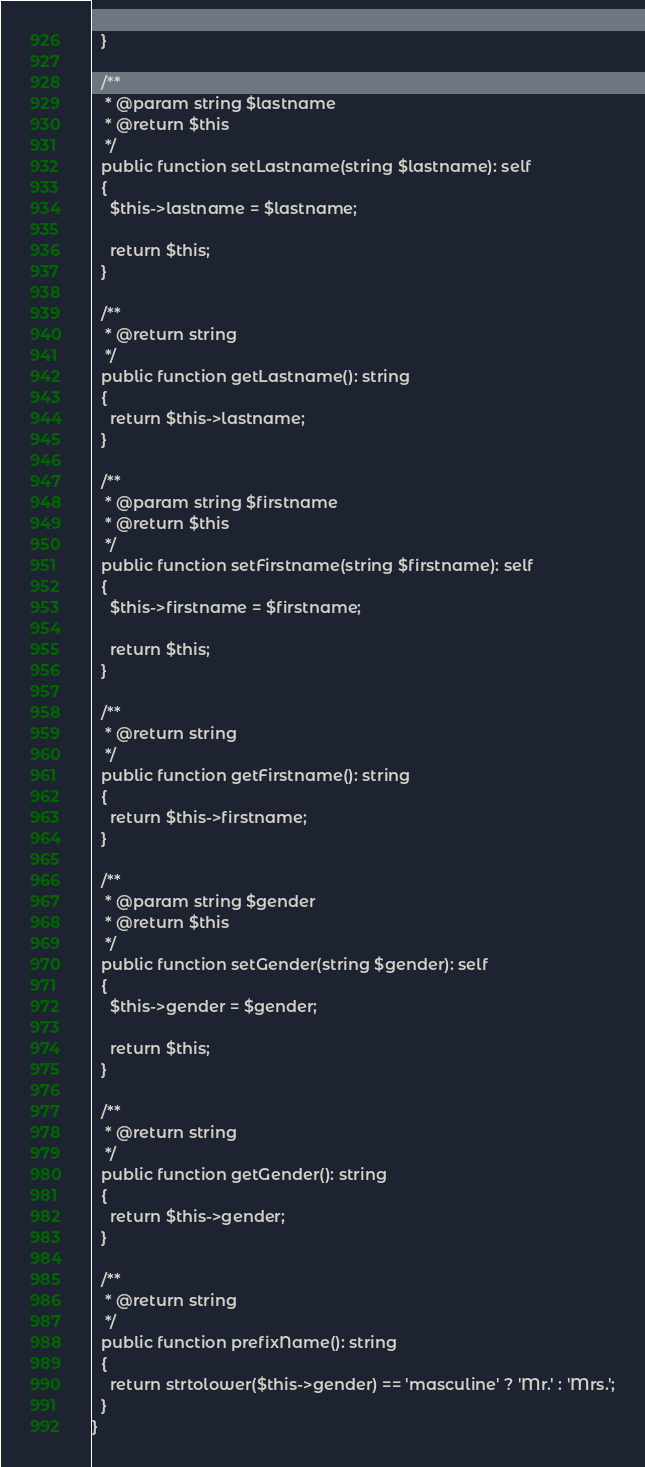<code> <loc_0><loc_0><loc_500><loc_500><_PHP_>  }

  /**
   * @param string $lastname
   * @return $this
   */
  public function setLastname(string $lastname): self
  {
    $this->lastname = $lastname;

    return $this;
  }

  /**
   * @return string
   */
  public function getLastname(): string
  {
    return $this->lastname;
  }

  /**
   * @param string $firstname
   * @return $this
   */
  public function setFirstname(string $firstname): self
  {
    $this->firstname = $firstname;

    return $this;
  }

  /**
   * @return string
   */
  public function getFirstname(): string
  {
    return $this->firstname;
  }

  /**
   * @param string $gender
   * @return $this
   */
  public function setGender(string $gender): self
  {
    $this->gender = $gender;

    return $this;
  }

  /**
   * @return string
   */
  public function getGender(): string
  {
    return $this->gender;
  }

  /**
   * @return string
   */
  public function prefixName(): string
  {
    return strtolower($this->gender) == 'masculine' ? 'Mr.' : 'Mrs.';
  }
}
</code> 